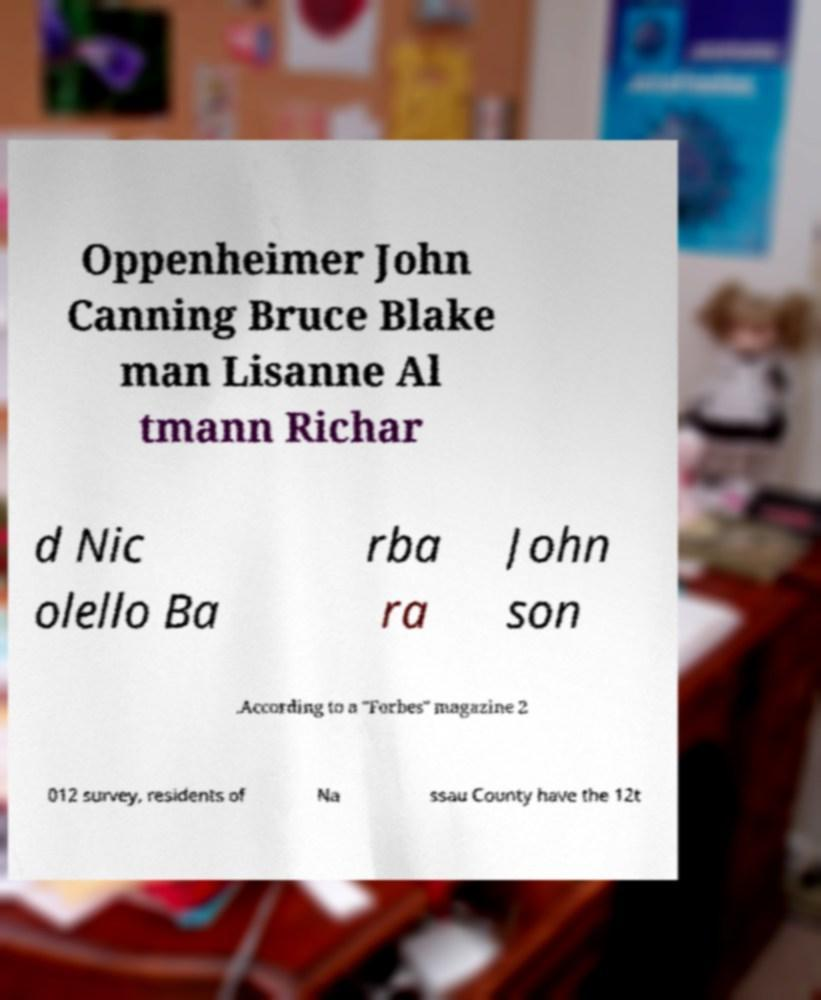Please read and relay the text visible in this image. What does it say? Oppenheimer John Canning Bruce Blake man Lisanne Al tmann Richar d Nic olello Ba rba ra John son .According to a "Forbes" magazine 2 012 survey, residents of Na ssau County have the 12t 